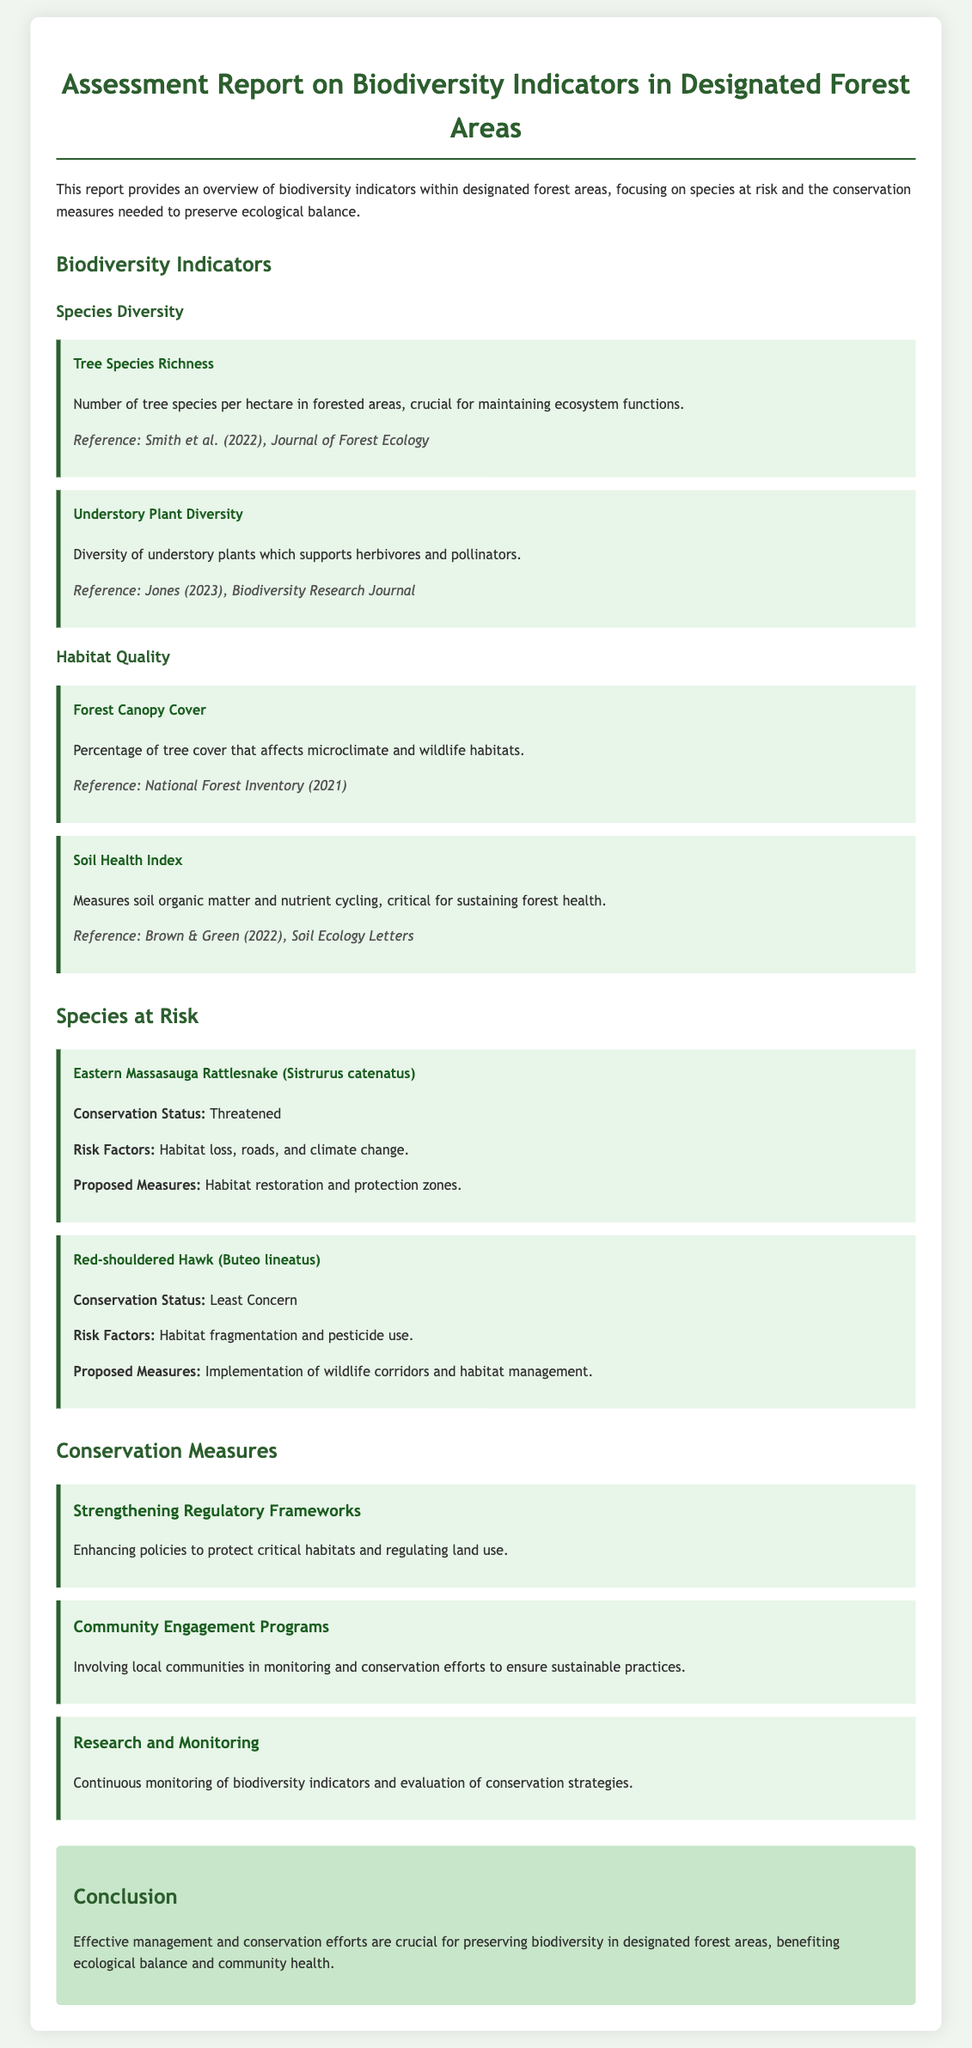what is the title of the report? The title of the report is provided at the top of the document, which encapsulates its content regarding biodiversity.
Answer: Assessment Report on Biodiversity Indicators in Designated Forest Areas how many tree species are mentioned as an indicator? The document lists a specific indicator related to tree species richness, highlighting its importance in forest ecology.
Answer: Tree Species Richness what is the conservation status of the Eastern Massasauga Rattlesnake? The conservation status is explicitly mentioned for species at risk within the report.
Answer: Threatened which species is noted for having its habitat affected by pesticides? The species in question is identified in the report alongside its risk factors, relating to habitat concerns.
Answer: Red-shouldered Hawk what is one proposed measure for the Eastern Massasauga Rattlesnake? Proposed measures for species at risk are outlined in the report, detailing actions required for their conservation.
Answer: Habitat restoration and protection zones what is one of the conservation measures mentioned? The report specifies different conservation measures aimed at enhancing biodiversity, focusing on regulatory and community efforts.
Answer: Strengthening Regulatory Frameworks how does the report suggest involving local communities? Community involvement is addressed within conservation strategies, indicating the approach to sustainable practices.
Answer: Community Engagement Programs what reference is cited for Forest Canopy Cover? The information on specific indicators is supported by references which substantiate the importance of the data presented.
Answer: National Forest Inventory (2021) 